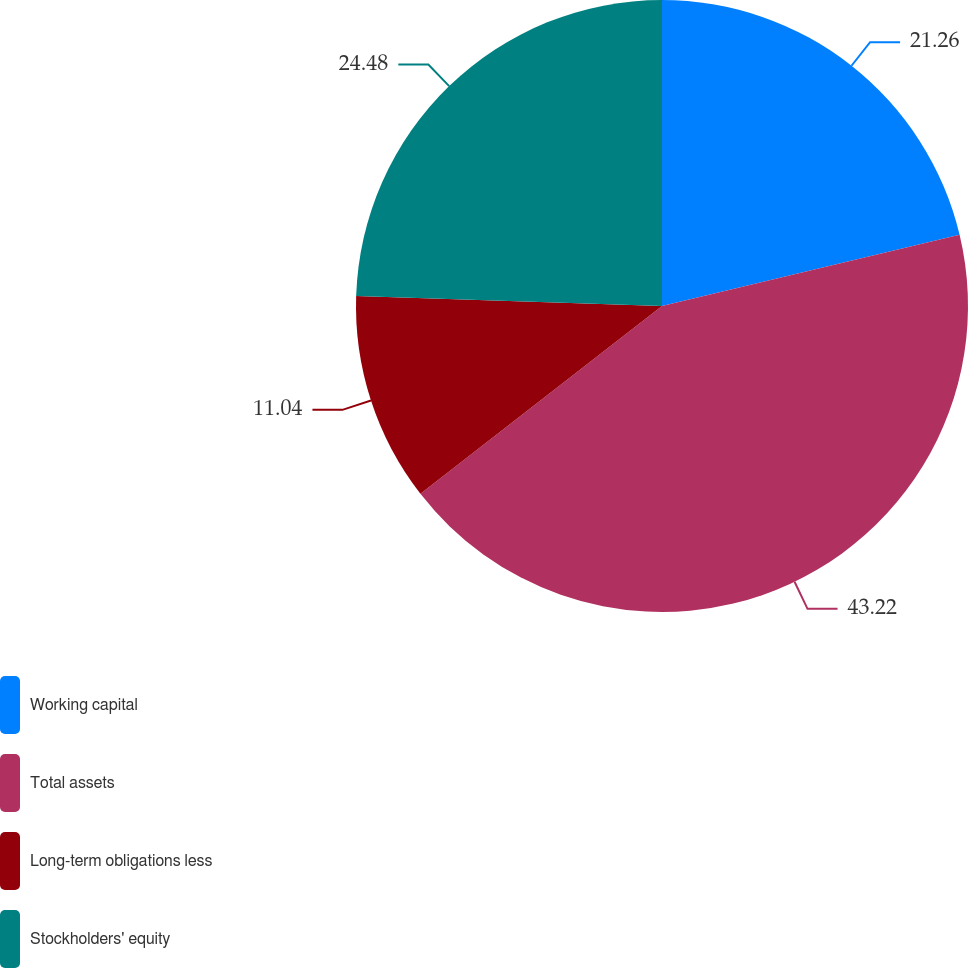<chart> <loc_0><loc_0><loc_500><loc_500><pie_chart><fcel>Working capital<fcel>Total assets<fcel>Long-term obligations less<fcel>Stockholders' equity<nl><fcel>21.26%<fcel>43.22%<fcel>11.04%<fcel>24.48%<nl></chart> 